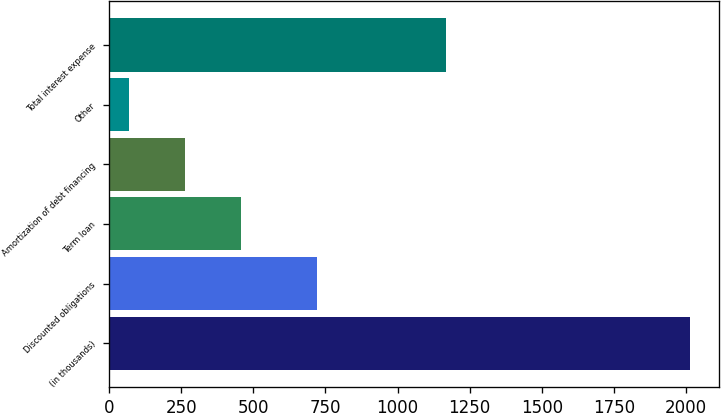Convert chart to OTSL. <chart><loc_0><loc_0><loc_500><loc_500><bar_chart><fcel>(in thousands)<fcel>Discounted obligations<fcel>Term loan<fcel>Amortization of debt financing<fcel>Other<fcel>Total interest expense<nl><fcel>2013<fcel>722<fcel>457<fcel>262.5<fcel>68<fcel>1169<nl></chart> 